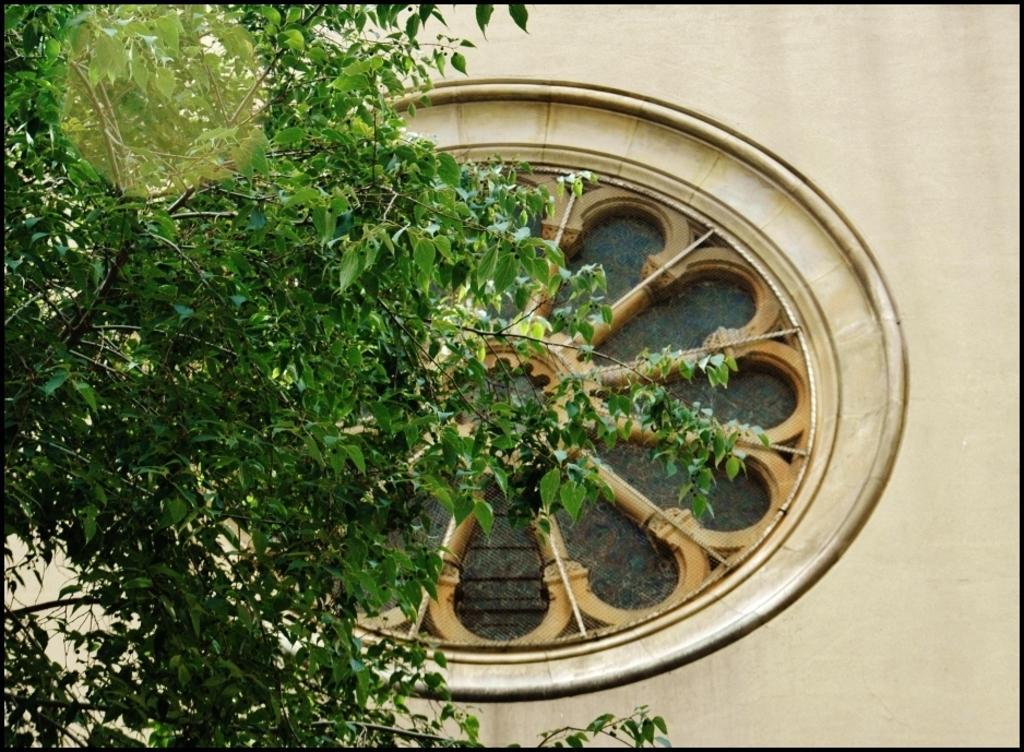Could you give a brief overview of what you see in this image? In the foreground of this image, on the left, there is a tree and a round shaped light shade. In the background, there is a wall and a wheel like structure on it. 